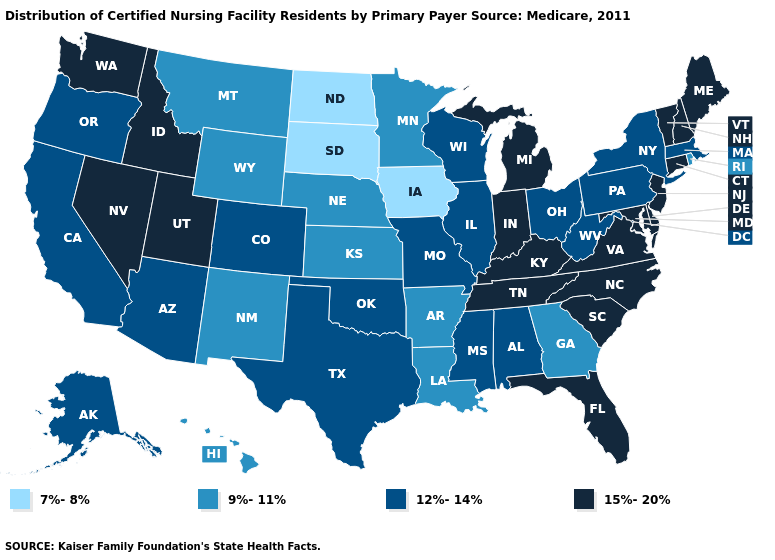What is the lowest value in the West?
Write a very short answer. 9%-11%. What is the lowest value in states that border Illinois?
Be succinct. 7%-8%. Name the states that have a value in the range 12%-14%?
Quick response, please. Alabama, Alaska, Arizona, California, Colorado, Illinois, Massachusetts, Mississippi, Missouri, New York, Ohio, Oklahoma, Oregon, Pennsylvania, Texas, West Virginia, Wisconsin. Which states have the lowest value in the USA?
Be succinct. Iowa, North Dakota, South Dakota. Does Florida have the highest value in the USA?
Quick response, please. Yes. What is the highest value in the USA?
Write a very short answer. 15%-20%. What is the value of Washington?
Answer briefly. 15%-20%. Name the states that have a value in the range 7%-8%?
Be succinct. Iowa, North Dakota, South Dakota. Which states have the lowest value in the South?
Be succinct. Arkansas, Georgia, Louisiana. What is the lowest value in states that border Louisiana?
Be succinct. 9%-11%. Among the states that border Rhode Island , does Massachusetts have the lowest value?
Keep it brief. Yes. Does Maine have a higher value than Illinois?
Give a very brief answer. Yes. Is the legend a continuous bar?
Short answer required. No. Does New Hampshire have the same value as Michigan?
Concise answer only. Yes. Does New York have a higher value than Montana?
Answer briefly. Yes. 